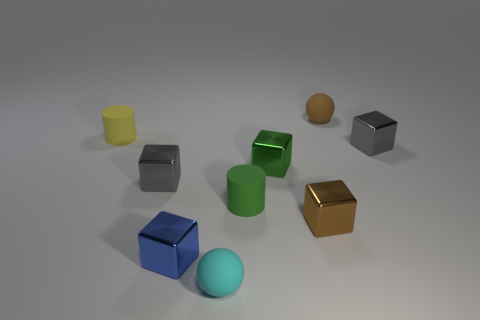Subtract all tiny blue metal blocks. How many blocks are left? 4 Subtract all yellow balls. How many gray blocks are left? 2 Subtract all gray blocks. How many blocks are left? 3 Add 1 yellow rubber cylinders. How many objects exist? 10 Subtract all blue cubes. Subtract all purple spheres. How many cubes are left? 4 Add 3 green matte cylinders. How many green matte cylinders are left? 4 Add 3 green shiny cubes. How many green shiny cubes exist? 4 Subtract 0 purple blocks. How many objects are left? 9 Subtract all cylinders. How many objects are left? 7 Subtract all tiny gray objects. Subtract all tiny balls. How many objects are left? 5 